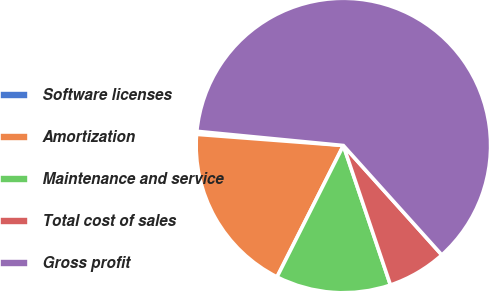Convert chart to OTSL. <chart><loc_0><loc_0><loc_500><loc_500><pie_chart><fcel>Software licenses<fcel>Amortization<fcel>Maintenance and service<fcel>Total cost of sales<fcel>Gross profit<nl><fcel>0.33%<fcel>18.77%<fcel>12.62%<fcel>6.48%<fcel>61.8%<nl></chart> 